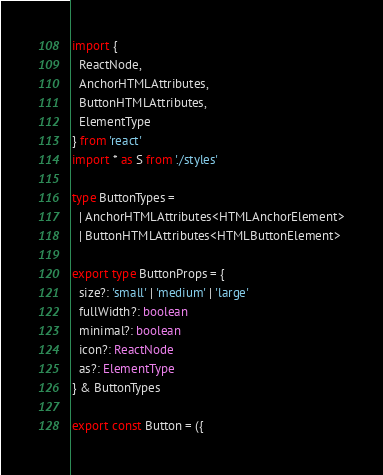Convert code to text. <code><loc_0><loc_0><loc_500><loc_500><_TypeScript_>import {
  ReactNode,
  AnchorHTMLAttributes,
  ButtonHTMLAttributes,
  ElementType
} from 'react'
import * as S from './styles'

type ButtonTypes =
  | AnchorHTMLAttributes<HTMLAnchorElement>
  | ButtonHTMLAttributes<HTMLButtonElement>

export type ButtonProps = {
  size?: 'small' | 'medium' | 'large'
  fullWidth?: boolean
  minimal?: boolean
  icon?: ReactNode
  as?: ElementType
} & ButtonTypes

export const Button = ({</code> 